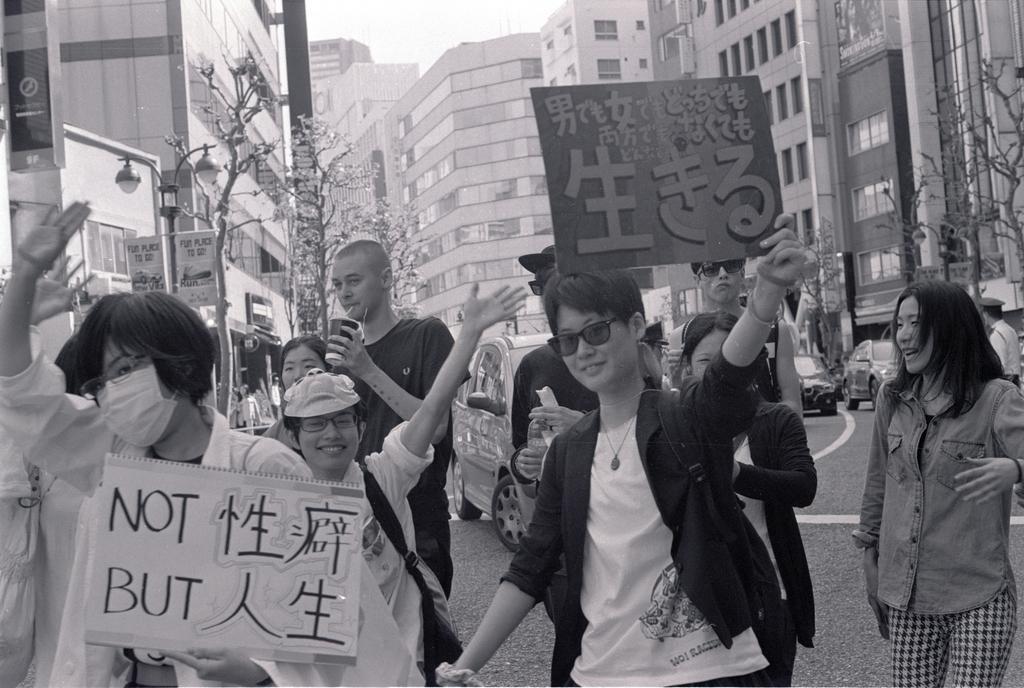Please provide a concise description of this image. In the image we can see there are people standing and they are holding banners in their hand. There are cars parked on the road and there are trees. Behind there are buildings and there is a street light pole. The image is in black and white colour. 